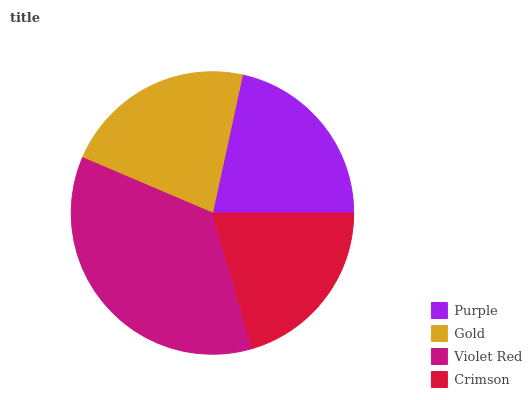Is Crimson the minimum?
Answer yes or no. Yes. Is Violet Red the maximum?
Answer yes or no. Yes. Is Gold the minimum?
Answer yes or no. No. Is Gold the maximum?
Answer yes or no. No. Is Gold greater than Purple?
Answer yes or no. Yes. Is Purple less than Gold?
Answer yes or no. Yes. Is Purple greater than Gold?
Answer yes or no. No. Is Gold less than Purple?
Answer yes or no. No. Is Gold the high median?
Answer yes or no. Yes. Is Purple the low median?
Answer yes or no. Yes. Is Violet Red the high median?
Answer yes or no. No. Is Gold the low median?
Answer yes or no. No. 